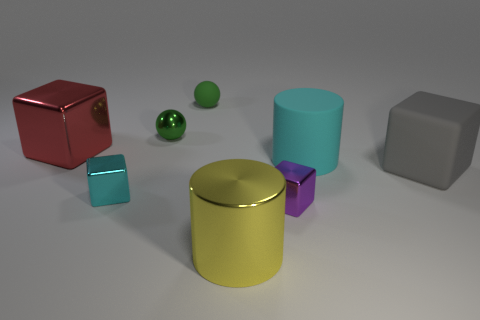What shape is the tiny thing that is both behind the cyan metallic block and in front of the green rubber ball?
Provide a short and direct response. Sphere. There is a small matte thing that is the same shape as the small green metallic thing; what color is it?
Provide a succinct answer. Green. What number of things are either large shiny objects to the left of the big yellow cylinder or small shiny things that are in front of the cyan cylinder?
Ensure brevity in your answer.  3. There is a green rubber thing; what shape is it?
Offer a very short reply. Sphere. What is the shape of the tiny rubber thing that is the same color as the small shiny ball?
Provide a short and direct response. Sphere. What number of big red objects are made of the same material as the purple block?
Make the answer very short. 1. The metallic cylinder has what color?
Keep it short and to the point. Yellow. There is another metal object that is the same size as the red metallic object; what color is it?
Offer a terse response. Yellow. Are there any balls of the same color as the large metallic block?
Keep it short and to the point. No. There is a big matte thing left of the matte cube; is it the same shape as the cyan thing in front of the big gray matte block?
Ensure brevity in your answer.  No. 